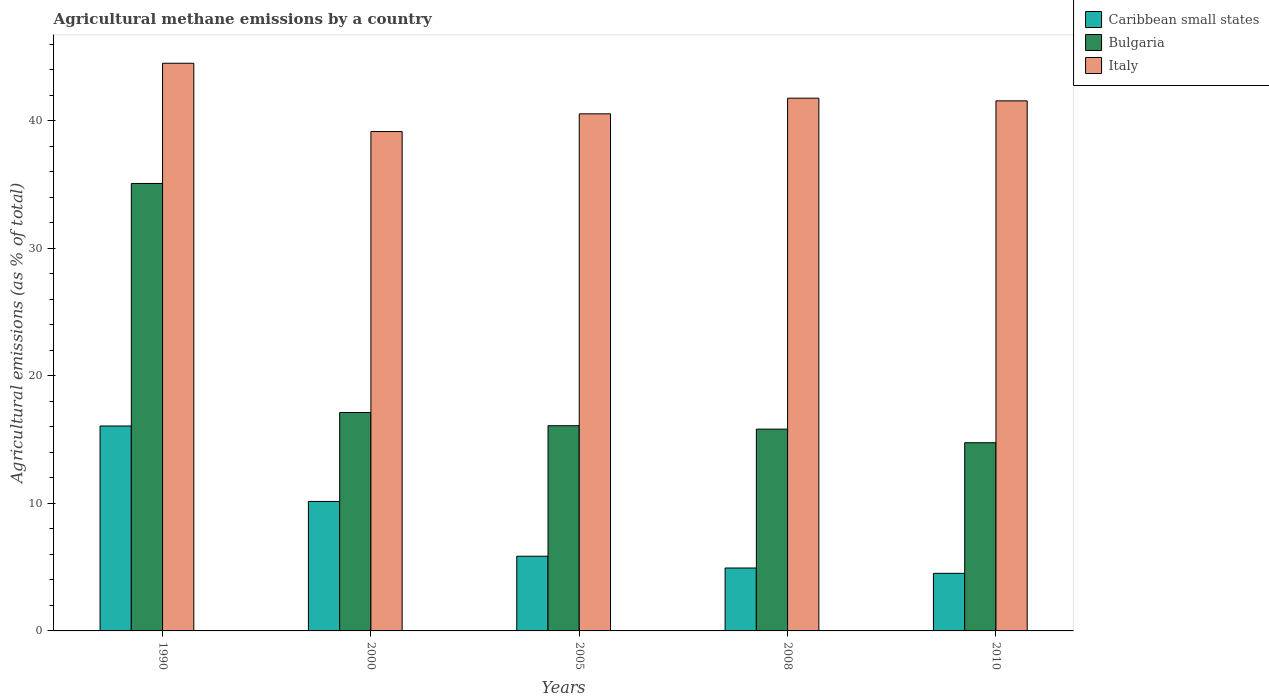How many different coloured bars are there?
Offer a terse response. 3. How many groups of bars are there?
Your response must be concise. 5. Are the number of bars on each tick of the X-axis equal?
Offer a very short reply. Yes. What is the label of the 4th group of bars from the left?
Keep it short and to the point. 2008. In how many cases, is the number of bars for a given year not equal to the number of legend labels?
Your response must be concise. 0. What is the amount of agricultural methane emitted in Caribbean small states in 2005?
Your response must be concise. 5.85. Across all years, what is the maximum amount of agricultural methane emitted in Caribbean small states?
Your answer should be very brief. 16.06. Across all years, what is the minimum amount of agricultural methane emitted in Bulgaria?
Give a very brief answer. 14.75. In which year was the amount of agricultural methane emitted in Italy minimum?
Keep it short and to the point. 2000. What is the total amount of agricultural methane emitted in Italy in the graph?
Offer a very short reply. 207.46. What is the difference between the amount of agricultural methane emitted in Caribbean small states in 2008 and that in 2010?
Offer a very short reply. 0.42. What is the difference between the amount of agricultural methane emitted in Bulgaria in 2000 and the amount of agricultural methane emitted in Caribbean small states in 1990?
Offer a terse response. 1.06. What is the average amount of agricultural methane emitted in Italy per year?
Make the answer very short. 41.49. In the year 2005, what is the difference between the amount of agricultural methane emitted in Caribbean small states and amount of agricultural methane emitted in Bulgaria?
Give a very brief answer. -10.23. In how many years, is the amount of agricultural methane emitted in Bulgaria greater than 30 %?
Your response must be concise. 1. What is the ratio of the amount of agricultural methane emitted in Caribbean small states in 1990 to that in 2005?
Give a very brief answer. 2.74. Is the difference between the amount of agricultural methane emitted in Caribbean small states in 2000 and 2005 greater than the difference between the amount of agricultural methane emitted in Bulgaria in 2000 and 2005?
Offer a terse response. Yes. What is the difference between the highest and the second highest amount of agricultural methane emitted in Italy?
Offer a terse response. 2.74. What is the difference between the highest and the lowest amount of agricultural methane emitted in Caribbean small states?
Provide a succinct answer. 11.55. In how many years, is the amount of agricultural methane emitted in Italy greater than the average amount of agricultural methane emitted in Italy taken over all years?
Keep it short and to the point. 3. What does the 2nd bar from the right in 2000 represents?
Offer a terse response. Bulgaria. Is it the case that in every year, the sum of the amount of agricultural methane emitted in Bulgaria and amount of agricultural methane emitted in Caribbean small states is greater than the amount of agricultural methane emitted in Italy?
Ensure brevity in your answer.  No. How many bars are there?
Offer a terse response. 15. How many years are there in the graph?
Keep it short and to the point. 5. What is the difference between two consecutive major ticks on the Y-axis?
Give a very brief answer. 10. Are the values on the major ticks of Y-axis written in scientific E-notation?
Offer a very short reply. No. How are the legend labels stacked?
Provide a short and direct response. Vertical. What is the title of the graph?
Your answer should be compact. Agricultural methane emissions by a country. What is the label or title of the X-axis?
Offer a terse response. Years. What is the label or title of the Y-axis?
Your response must be concise. Agricultural emissions (as % of total). What is the Agricultural emissions (as % of total) in Caribbean small states in 1990?
Offer a terse response. 16.06. What is the Agricultural emissions (as % of total) in Bulgaria in 1990?
Offer a terse response. 35.07. What is the Agricultural emissions (as % of total) in Italy in 1990?
Provide a short and direct response. 44.49. What is the Agricultural emissions (as % of total) of Caribbean small states in 2000?
Give a very brief answer. 10.15. What is the Agricultural emissions (as % of total) in Bulgaria in 2000?
Offer a terse response. 17.12. What is the Agricultural emissions (as % of total) of Italy in 2000?
Give a very brief answer. 39.14. What is the Agricultural emissions (as % of total) in Caribbean small states in 2005?
Your response must be concise. 5.85. What is the Agricultural emissions (as % of total) in Bulgaria in 2005?
Ensure brevity in your answer.  16.08. What is the Agricultural emissions (as % of total) of Italy in 2005?
Give a very brief answer. 40.53. What is the Agricultural emissions (as % of total) in Caribbean small states in 2008?
Provide a short and direct response. 4.93. What is the Agricultural emissions (as % of total) in Bulgaria in 2008?
Offer a very short reply. 15.82. What is the Agricultural emissions (as % of total) of Italy in 2008?
Keep it short and to the point. 41.76. What is the Agricultural emissions (as % of total) in Caribbean small states in 2010?
Provide a short and direct response. 4.51. What is the Agricultural emissions (as % of total) of Bulgaria in 2010?
Your response must be concise. 14.75. What is the Agricultural emissions (as % of total) in Italy in 2010?
Keep it short and to the point. 41.55. Across all years, what is the maximum Agricultural emissions (as % of total) of Caribbean small states?
Your response must be concise. 16.06. Across all years, what is the maximum Agricultural emissions (as % of total) of Bulgaria?
Keep it short and to the point. 35.07. Across all years, what is the maximum Agricultural emissions (as % of total) of Italy?
Your response must be concise. 44.49. Across all years, what is the minimum Agricultural emissions (as % of total) of Caribbean small states?
Make the answer very short. 4.51. Across all years, what is the minimum Agricultural emissions (as % of total) of Bulgaria?
Offer a terse response. 14.75. Across all years, what is the minimum Agricultural emissions (as % of total) of Italy?
Keep it short and to the point. 39.14. What is the total Agricultural emissions (as % of total) of Caribbean small states in the graph?
Offer a terse response. 41.51. What is the total Agricultural emissions (as % of total) of Bulgaria in the graph?
Keep it short and to the point. 98.84. What is the total Agricultural emissions (as % of total) of Italy in the graph?
Keep it short and to the point. 207.46. What is the difference between the Agricultural emissions (as % of total) in Caribbean small states in 1990 and that in 2000?
Your answer should be very brief. 5.91. What is the difference between the Agricultural emissions (as % of total) of Bulgaria in 1990 and that in 2000?
Your answer should be very brief. 17.95. What is the difference between the Agricultural emissions (as % of total) in Italy in 1990 and that in 2000?
Keep it short and to the point. 5.35. What is the difference between the Agricultural emissions (as % of total) of Caribbean small states in 1990 and that in 2005?
Your answer should be compact. 10.21. What is the difference between the Agricultural emissions (as % of total) in Bulgaria in 1990 and that in 2005?
Keep it short and to the point. 18.99. What is the difference between the Agricultural emissions (as % of total) of Italy in 1990 and that in 2005?
Make the answer very short. 3.96. What is the difference between the Agricultural emissions (as % of total) in Caribbean small states in 1990 and that in 2008?
Ensure brevity in your answer.  11.13. What is the difference between the Agricultural emissions (as % of total) of Bulgaria in 1990 and that in 2008?
Your answer should be compact. 19.26. What is the difference between the Agricultural emissions (as % of total) of Italy in 1990 and that in 2008?
Keep it short and to the point. 2.74. What is the difference between the Agricultural emissions (as % of total) of Caribbean small states in 1990 and that in 2010?
Provide a succinct answer. 11.55. What is the difference between the Agricultural emissions (as % of total) of Bulgaria in 1990 and that in 2010?
Keep it short and to the point. 20.32. What is the difference between the Agricultural emissions (as % of total) of Italy in 1990 and that in 2010?
Your answer should be very brief. 2.95. What is the difference between the Agricultural emissions (as % of total) in Caribbean small states in 2000 and that in 2005?
Offer a terse response. 4.29. What is the difference between the Agricultural emissions (as % of total) of Bulgaria in 2000 and that in 2005?
Your answer should be very brief. 1.04. What is the difference between the Agricultural emissions (as % of total) of Italy in 2000 and that in 2005?
Your answer should be compact. -1.39. What is the difference between the Agricultural emissions (as % of total) of Caribbean small states in 2000 and that in 2008?
Provide a short and direct response. 5.22. What is the difference between the Agricultural emissions (as % of total) of Bulgaria in 2000 and that in 2008?
Provide a short and direct response. 1.3. What is the difference between the Agricultural emissions (as % of total) of Italy in 2000 and that in 2008?
Your answer should be compact. -2.62. What is the difference between the Agricultural emissions (as % of total) of Caribbean small states in 2000 and that in 2010?
Ensure brevity in your answer.  5.63. What is the difference between the Agricultural emissions (as % of total) in Bulgaria in 2000 and that in 2010?
Ensure brevity in your answer.  2.37. What is the difference between the Agricultural emissions (as % of total) of Italy in 2000 and that in 2010?
Keep it short and to the point. -2.41. What is the difference between the Agricultural emissions (as % of total) in Caribbean small states in 2005 and that in 2008?
Give a very brief answer. 0.92. What is the difference between the Agricultural emissions (as % of total) of Bulgaria in 2005 and that in 2008?
Your answer should be very brief. 0.27. What is the difference between the Agricultural emissions (as % of total) of Italy in 2005 and that in 2008?
Your answer should be very brief. -1.23. What is the difference between the Agricultural emissions (as % of total) of Caribbean small states in 2005 and that in 2010?
Your answer should be compact. 1.34. What is the difference between the Agricultural emissions (as % of total) in Bulgaria in 2005 and that in 2010?
Your answer should be compact. 1.33. What is the difference between the Agricultural emissions (as % of total) of Italy in 2005 and that in 2010?
Give a very brief answer. -1.02. What is the difference between the Agricultural emissions (as % of total) in Caribbean small states in 2008 and that in 2010?
Offer a terse response. 0.42. What is the difference between the Agricultural emissions (as % of total) in Bulgaria in 2008 and that in 2010?
Your response must be concise. 1.07. What is the difference between the Agricultural emissions (as % of total) in Italy in 2008 and that in 2010?
Offer a terse response. 0.21. What is the difference between the Agricultural emissions (as % of total) of Caribbean small states in 1990 and the Agricultural emissions (as % of total) of Bulgaria in 2000?
Provide a succinct answer. -1.06. What is the difference between the Agricultural emissions (as % of total) in Caribbean small states in 1990 and the Agricultural emissions (as % of total) in Italy in 2000?
Your answer should be very brief. -23.08. What is the difference between the Agricultural emissions (as % of total) of Bulgaria in 1990 and the Agricultural emissions (as % of total) of Italy in 2000?
Make the answer very short. -4.07. What is the difference between the Agricultural emissions (as % of total) of Caribbean small states in 1990 and the Agricultural emissions (as % of total) of Bulgaria in 2005?
Offer a terse response. -0.02. What is the difference between the Agricultural emissions (as % of total) of Caribbean small states in 1990 and the Agricultural emissions (as % of total) of Italy in 2005?
Your response must be concise. -24.47. What is the difference between the Agricultural emissions (as % of total) of Bulgaria in 1990 and the Agricultural emissions (as % of total) of Italy in 2005?
Offer a terse response. -5.46. What is the difference between the Agricultural emissions (as % of total) in Caribbean small states in 1990 and the Agricultural emissions (as % of total) in Bulgaria in 2008?
Provide a succinct answer. 0.25. What is the difference between the Agricultural emissions (as % of total) in Caribbean small states in 1990 and the Agricultural emissions (as % of total) in Italy in 2008?
Keep it short and to the point. -25.69. What is the difference between the Agricultural emissions (as % of total) in Bulgaria in 1990 and the Agricultural emissions (as % of total) in Italy in 2008?
Offer a very short reply. -6.68. What is the difference between the Agricultural emissions (as % of total) in Caribbean small states in 1990 and the Agricultural emissions (as % of total) in Bulgaria in 2010?
Keep it short and to the point. 1.31. What is the difference between the Agricultural emissions (as % of total) of Caribbean small states in 1990 and the Agricultural emissions (as % of total) of Italy in 2010?
Your answer should be very brief. -25.48. What is the difference between the Agricultural emissions (as % of total) in Bulgaria in 1990 and the Agricultural emissions (as % of total) in Italy in 2010?
Give a very brief answer. -6.47. What is the difference between the Agricultural emissions (as % of total) in Caribbean small states in 2000 and the Agricultural emissions (as % of total) in Bulgaria in 2005?
Keep it short and to the point. -5.94. What is the difference between the Agricultural emissions (as % of total) of Caribbean small states in 2000 and the Agricultural emissions (as % of total) of Italy in 2005?
Offer a terse response. -30.38. What is the difference between the Agricultural emissions (as % of total) in Bulgaria in 2000 and the Agricultural emissions (as % of total) in Italy in 2005?
Provide a succinct answer. -23.41. What is the difference between the Agricultural emissions (as % of total) in Caribbean small states in 2000 and the Agricultural emissions (as % of total) in Bulgaria in 2008?
Provide a succinct answer. -5.67. What is the difference between the Agricultural emissions (as % of total) of Caribbean small states in 2000 and the Agricultural emissions (as % of total) of Italy in 2008?
Keep it short and to the point. -31.61. What is the difference between the Agricultural emissions (as % of total) in Bulgaria in 2000 and the Agricultural emissions (as % of total) in Italy in 2008?
Provide a succinct answer. -24.64. What is the difference between the Agricultural emissions (as % of total) of Caribbean small states in 2000 and the Agricultural emissions (as % of total) of Bulgaria in 2010?
Provide a short and direct response. -4.6. What is the difference between the Agricultural emissions (as % of total) in Caribbean small states in 2000 and the Agricultural emissions (as % of total) in Italy in 2010?
Provide a short and direct response. -31.4. What is the difference between the Agricultural emissions (as % of total) of Bulgaria in 2000 and the Agricultural emissions (as % of total) of Italy in 2010?
Your answer should be very brief. -24.43. What is the difference between the Agricultural emissions (as % of total) of Caribbean small states in 2005 and the Agricultural emissions (as % of total) of Bulgaria in 2008?
Your answer should be compact. -9.96. What is the difference between the Agricultural emissions (as % of total) in Caribbean small states in 2005 and the Agricultural emissions (as % of total) in Italy in 2008?
Your answer should be very brief. -35.9. What is the difference between the Agricultural emissions (as % of total) in Bulgaria in 2005 and the Agricultural emissions (as % of total) in Italy in 2008?
Offer a very short reply. -25.67. What is the difference between the Agricultural emissions (as % of total) in Caribbean small states in 2005 and the Agricultural emissions (as % of total) in Bulgaria in 2010?
Your answer should be compact. -8.9. What is the difference between the Agricultural emissions (as % of total) in Caribbean small states in 2005 and the Agricultural emissions (as % of total) in Italy in 2010?
Ensure brevity in your answer.  -35.69. What is the difference between the Agricultural emissions (as % of total) of Bulgaria in 2005 and the Agricultural emissions (as % of total) of Italy in 2010?
Your response must be concise. -25.46. What is the difference between the Agricultural emissions (as % of total) in Caribbean small states in 2008 and the Agricultural emissions (as % of total) in Bulgaria in 2010?
Your response must be concise. -9.82. What is the difference between the Agricultural emissions (as % of total) in Caribbean small states in 2008 and the Agricultural emissions (as % of total) in Italy in 2010?
Offer a terse response. -36.61. What is the difference between the Agricultural emissions (as % of total) in Bulgaria in 2008 and the Agricultural emissions (as % of total) in Italy in 2010?
Give a very brief answer. -25.73. What is the average Agricultural emissions (as % of total) of Caribbean small states per year?
Provide a succinct answer. 8.3. What is the average Agricultural emissions (as % of total) in Bulgaria per year?
Your answer should be very brief. 19.77. What is the average Agricultural emissions (as % of total) in Italy per year?
Provide a succinct answer. 41.49. In the year 1990, what is the difference between the Agricultural emissions (as % of total) of Caribbean small states and Agricultural emissions (as % of total) of Bulgaria?
Give a very brief answer. -19.01. In the year 1990, what is the difference between the Agricultural emissions (as % of total) of Caribbean small states and Agricultural emissions (as % of total) of Italy?
Keep it short and to the point. -28.43. In the year 1990, what is the difference between the Agricultural emissions (as % of total) of Bulgaria and Agricultural emissions (as % of total) of Italy?
Provide a short and direct response. -9.42. In the year 2000, what is the difference between the Agricultural emissions (as % of total) of Caribbean small states and Agricultural emissions (as % of total) of Bulgaria?
Offer a very short reply. -6.97. In the year 2000, what is the difference between the Agricultural emissions (as % of total) of Caribbean small states and Agricultural emissions (as % of total) of Italy?
Offer a very short reply. -28.99. In the year 2000, what is the difference between the Agricultural emissions (as % of total) of Bulgaria and Agricultural emissions (as % of total) of Italy?
Your answer should be compact. -22.02. In the year 2005, what is the difference between the Agricultural emissions (as % of total) of Caribbean small states and Agricultural emissions (as % of total) of Bulgaria?
Your answer should be very brief. -10.23. In the year 2005, what is the difference between the Agricultural emissions (as % of total) in Caribbean small states and Agricultural emissions (as % of total) in Italy?
Ensure brevity in your answer.  -34.67. In the year 2005, what is the difference between the Agricultural emissions (as % of total) in Bulgaria and Agricultural emissions (as % of total) in Italy?
Give a very brief answer. -24.45. In the year 2008, what is the difference between the Agricultural emissions (as % of total) in Caribbean small states and Agricultural emissions (as % of total) in Bulgaria?
Your response must be concise. -10.88. In the year 2008, what is the difference between the Agricultural emissions (as % of total) in Caribbean small states and Agricultural emissions (as % of total) in Italy?
Give a very brief answer. -36.82. In the year 2008, what is the difference between the Agricultural emissions (as % of total) of Bulgaria and Agricultural emissions (as % of total) of Italy?
Your answer should be compact. -25.94. In the year 2010, what is the difference between the Agricultural emissions (as % of total) in Caribbean small states and Agricultural emissions (as % of total) in Bulgaria?
Your answer should be very brief. -10.24. In the year 2010, what is the difference between the Agricultural emissions (as % of total) of Caribbean small states and Agricultural emissions (as % of total) of Italy?
Your answer should be very brief. -37.03. In the year 2010, what is the difference between the Agricultural emissions (as % of total) in Bulgaria and Agricultural emissions (as % of total) in Italy?
Provide a short and direct response. -26.8. What is the ratio of the Agricultural emissions (as % of total) of Caribbean small states in 1990 to that in 2000?
Provide a short and direct response. 1.58. What is the ratio of the Agricultural emissions (as % of total) of Bulgaria in 1990 to that in 2000?
Provide a succinct answer. 2.05. What is the ratio of the Agricultural emissions (as % of total) of Italy in 1990 to that in 2000?
Give a very brief answer. 1.14. What is the ratio of the Agricultural emissions (as % of total) of Caribbean small states in 1990 to that in 2005?
Ensure brevity in your answer.  2.74. What is the ratio of the Agricultural emissions (as % of total) of Bulgaria in 1990 to that in 2005?
Provide a succinct answer. 2.18. What is the ratio of the Agricultural emissions (as % of total) of Italy in 1990 to that in 2005?
Your response must be concise. 1.1. What is the ratio of the Agricultural emissions (as % of total) of Caribbean small states in 1990 to that in 2008?
Offer a terse response. 3.26. What is the ratio of the Agricultural emissions (as % of total) in Bulgaria in 1990 to that in 2008?
Give a very brief answer. 2.22. What is the ratio of the Agricultural emissions (as % of total) in Italy in 1990 to that in 2008?
Your answer should be very brief. 1.07. What is the ratio of the Agricultural emissions (as % of total) in Caribbean small states in 1990 to that in 2010?
Give a very brief answer. 3.56. What is the ratio of the Agricultural emissions (as % of total) of Bulgaria in 1990 to that in 2010?
Keep it short and to the point. 2.38. What is the ratio of the Agricultural emissions (as % of total) of Italy in 1990 to that in 2010?
Offer a very short reply. 1.07. What is the ratio of the Agricultural emissions (as % of total) in Caribbean small states in 2000 to that in 2005?
Ensure brevity in your answer.  1.73. What is the ratio of the Agricultural emissions (as % of total) in Bulgaria in 2000 to that in 2005?
Provide a succinct answer. 1.06. What is the ratio of the Agricultural emissions (as % of total) in Italy in 2000 to that in 2005?
Provide a short and direct response. 0.97. What is the ratio of the Agricultural emissions (as % of total) in Caribbean small states in 2000 to that in 2008?
Make the answer very short. 2.06. What is the ratio of the Agricultural emissions (as % of total) of Bulgaria in 2000 to that in 2008?
Ensure brevity in your answer.  1.08. What is the ratio of the Agricultural emissions (as % of total) of Italy in 2000 to that in 2008?
Ensure brevity in your answer.  0.94. What is the ratio of the Agricultural emissions (as % of total) in Caribbean small states in 2000 to that in 2010?
Offer a very short reply. 2.25. What is the ratio of the Agricultural emissions (as % of total) in Bulgaria in 2000 to that in 2010?
Ensure brevity in your answer.  1.16. What is the ratio of the Agricultural emissions (as % of total) of Italy in 2000 to that in 2010?
Provide a succinct answer. 0.94. What is the ratio of the Agricultural emissions (as % of total) in Caribbean small states in 2005 to that in 2008?
Offer a terse response. 1.19. What is the ratio of the Agricultural emissions (as % of total) in Bulgaria in 2005 to that in 2008?
Ensure brevity in your answer.  1.02. What is the ratio of the Agricultural emissions (as % of total) of Italy in 2005 to that in 2008?
Give a very brief answer. 0.97. What is the ratio of the Agricultural emissions (as % of total) in Caribbean small states in 2005 to that in 2010?
Your answer should be compact. 1.3. What is the ratio of the Agricultural emissions (as % of total) in Bulgaria in 2005 to that in 2010?
Give a very brief answer. 1.09. What is the ratio of the Agricultural emissions (as % of total) of Italy in 2005 to that in 2010?
Offer a terse response. 0.98. What is the ratio of the Agricultural emissions (as % of total) of Caribbean small states in 2008 to that in 2010?
Give a very brief answer. 1.09. What is the ratio of the Agricultural emissions (as % of total) of Bulgaria in 2008 to that in 2010?
Offer a terse response. 1.07. What is the ratio of the Agricultural emissions (as % of total) of Italy in 2008 to that in 2010?
Provide a short and direct response. 1. What is the difference between the highest and the second highest Agricultural emissions (as % of total) of Caribbean small states?
Ensure brevity in your answer.  5.91. What is the difference between the highest and the second highest Agricultural emissions (as % of total) of Bulgaria?
Offer a terse response. 17.95. What is the difference between the highest and the second highest Agricultural emissions (as % of total) in Italy?
Give a very brief answer. 2.74. What is the difference between the highest and the lowest Agricultural emissions (as % of total) in Caribbean small states?
Provide a short and direct response. 11.55. What is the difference between the highest and the lowest Agricultural emissions (as % of total) in Bulgaria?
Keep it short and to the point. 20.32. What is the difference between the highest and the lowest Agricultural emissions (as % of total) of Italy?
Provide a succinct answer. 5.35. 